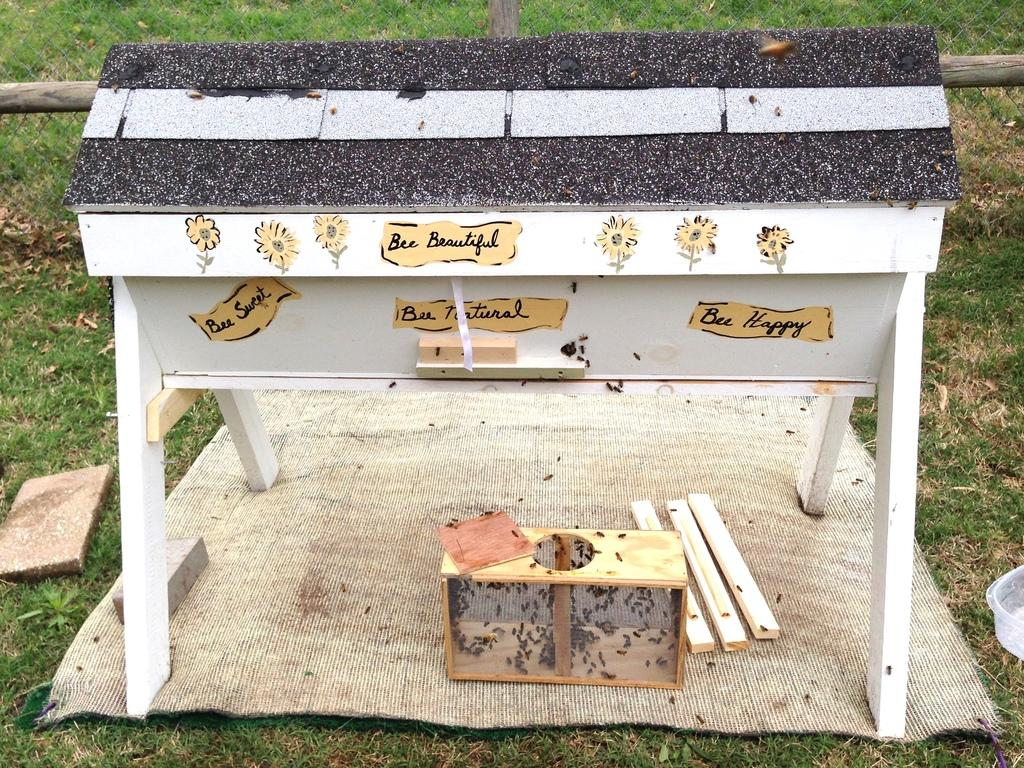Provide a one-sentence caption for the provided image. Handmade beehive with stickers stating Bee Happy, Bee Beautiful, Bee Natural, and Bee Sweet stuck on the front. 